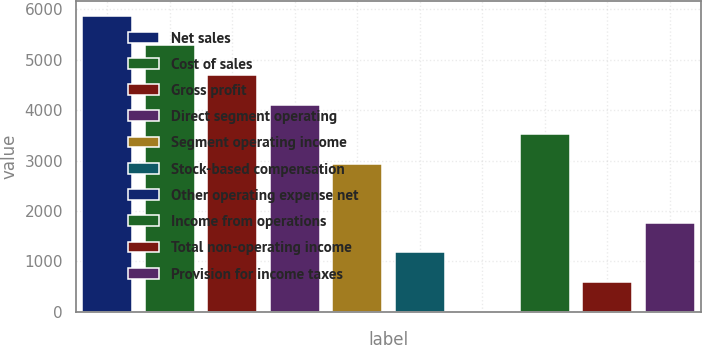Convert chart. <chart><loc_0><loc_0><loc_500><loc_500><bar_chart><fcel>Net sales<fcel>Cost of sales<fcel>Gross profit<fcel>Direct segment operating<fcel>Segment operating income<fcel>Stock-based compensation<fcel>Other operating expense net<fcel>Income from operations<fcel>Total non-operating income<fcel>Provision for income taxes<nl><fcel>5869<fcel>5283.1<fcel>4697.2<fcel>4111.3<fcel>2939.5<fcel>1181.8<fcel>10<fcel>3525.4<fcel>595.9<fcel>1767.7<nl></chart> 